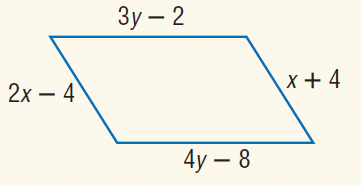Answer the mathemtical geometry problem and directly provide the correct option letter.
Question: Find x so that the quadrilateral is a parallelogram.
Choices: A: 4 B: 8 C: 16 D: 24 B 